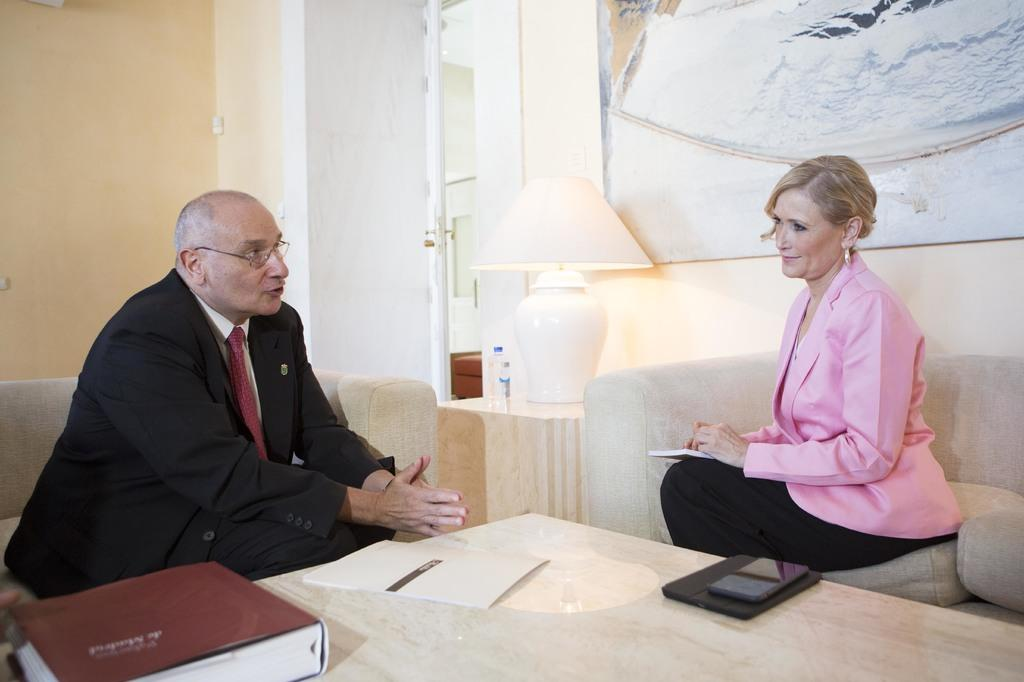Who can be seen sitting in the image? There is a man and a woman sitting in the image. What is present on the table in the image? There is a book and a paper on the table. Can you describe the lighting in the image? There is a lamp in the background of the image. What is visible on the wall in the background of the image? There is a painting on a wall in the background of the image. What type of cracker is being used to create the painting in the image? There is no cracker present in the image, and the painting is not being created in the image. 